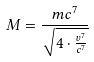Convert formula to latex. <formula><loc_0><loc_0><loc_500><loc_500>M = \frac { m c ^ { 7 } } { \sqrt { 4 \cdot \frac { v ^ { 7 } } { c ^ { 7 } } } }</formula> 